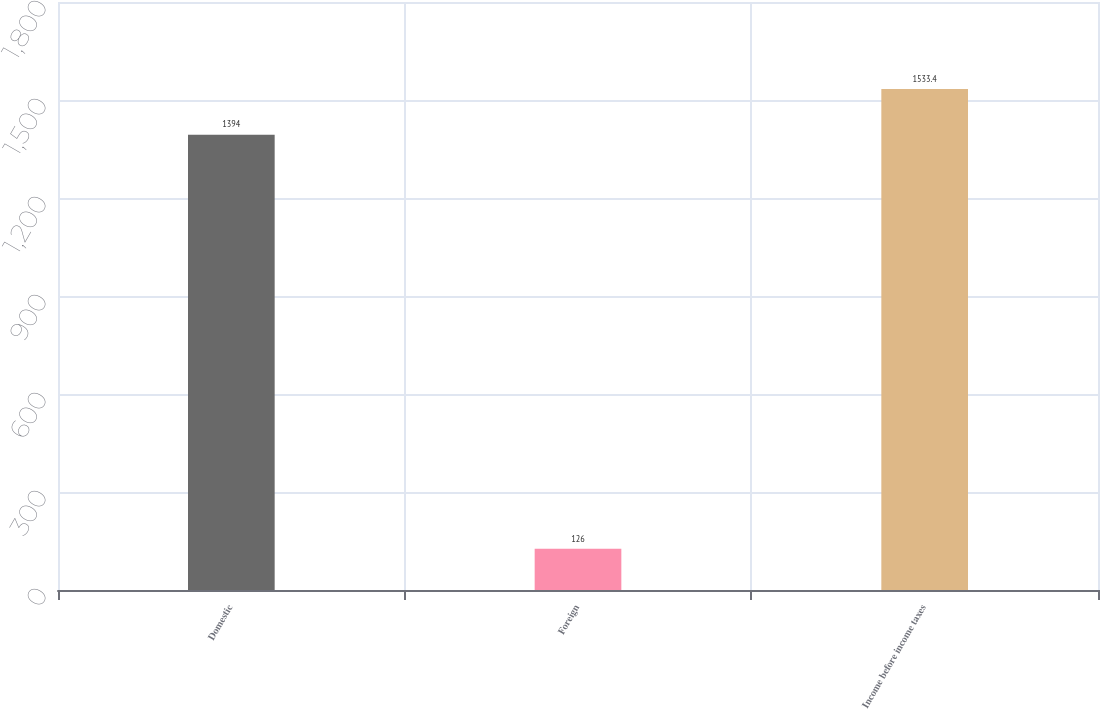Convert chart. <chart><loc_0><loc_0><loc_500><loc_500><bar_chart><fcel>Domestic<fcel>Foreign<fcel>Income before income taxes<nl><fcel>1394<fcel>126<fcel>1533.4<nl></chart> 